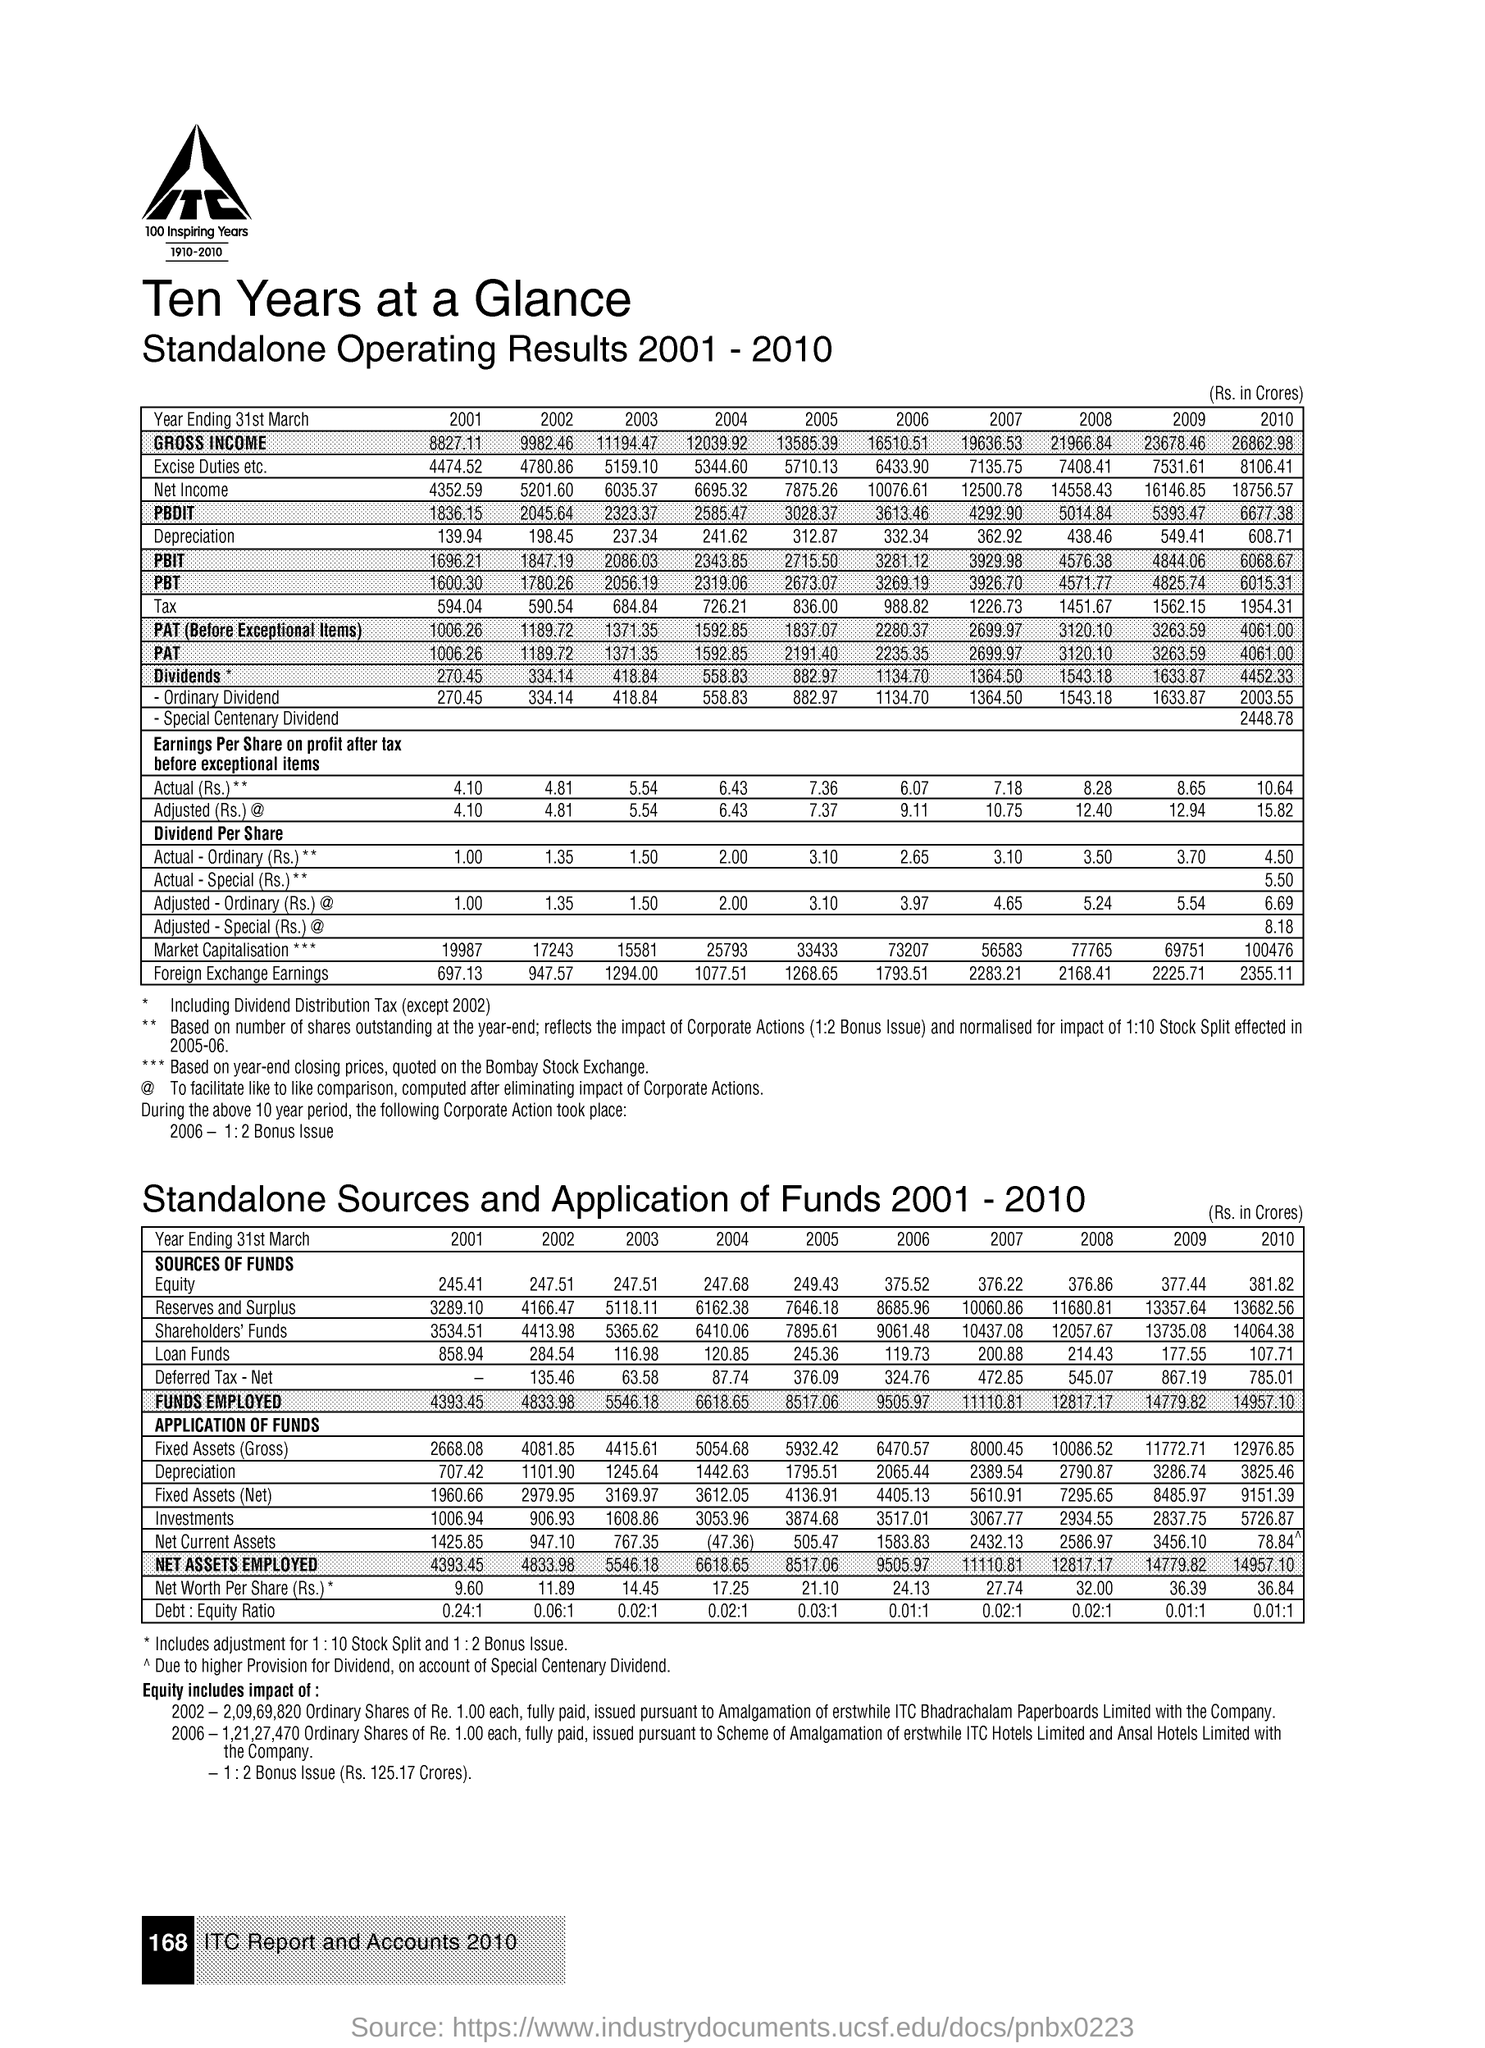What is the first title in the document?
Your answer should be compact. Ten years at a glance. What is the second title in the document?
Provide a succinct answer. Standalone Operating Results 2001-2010. 